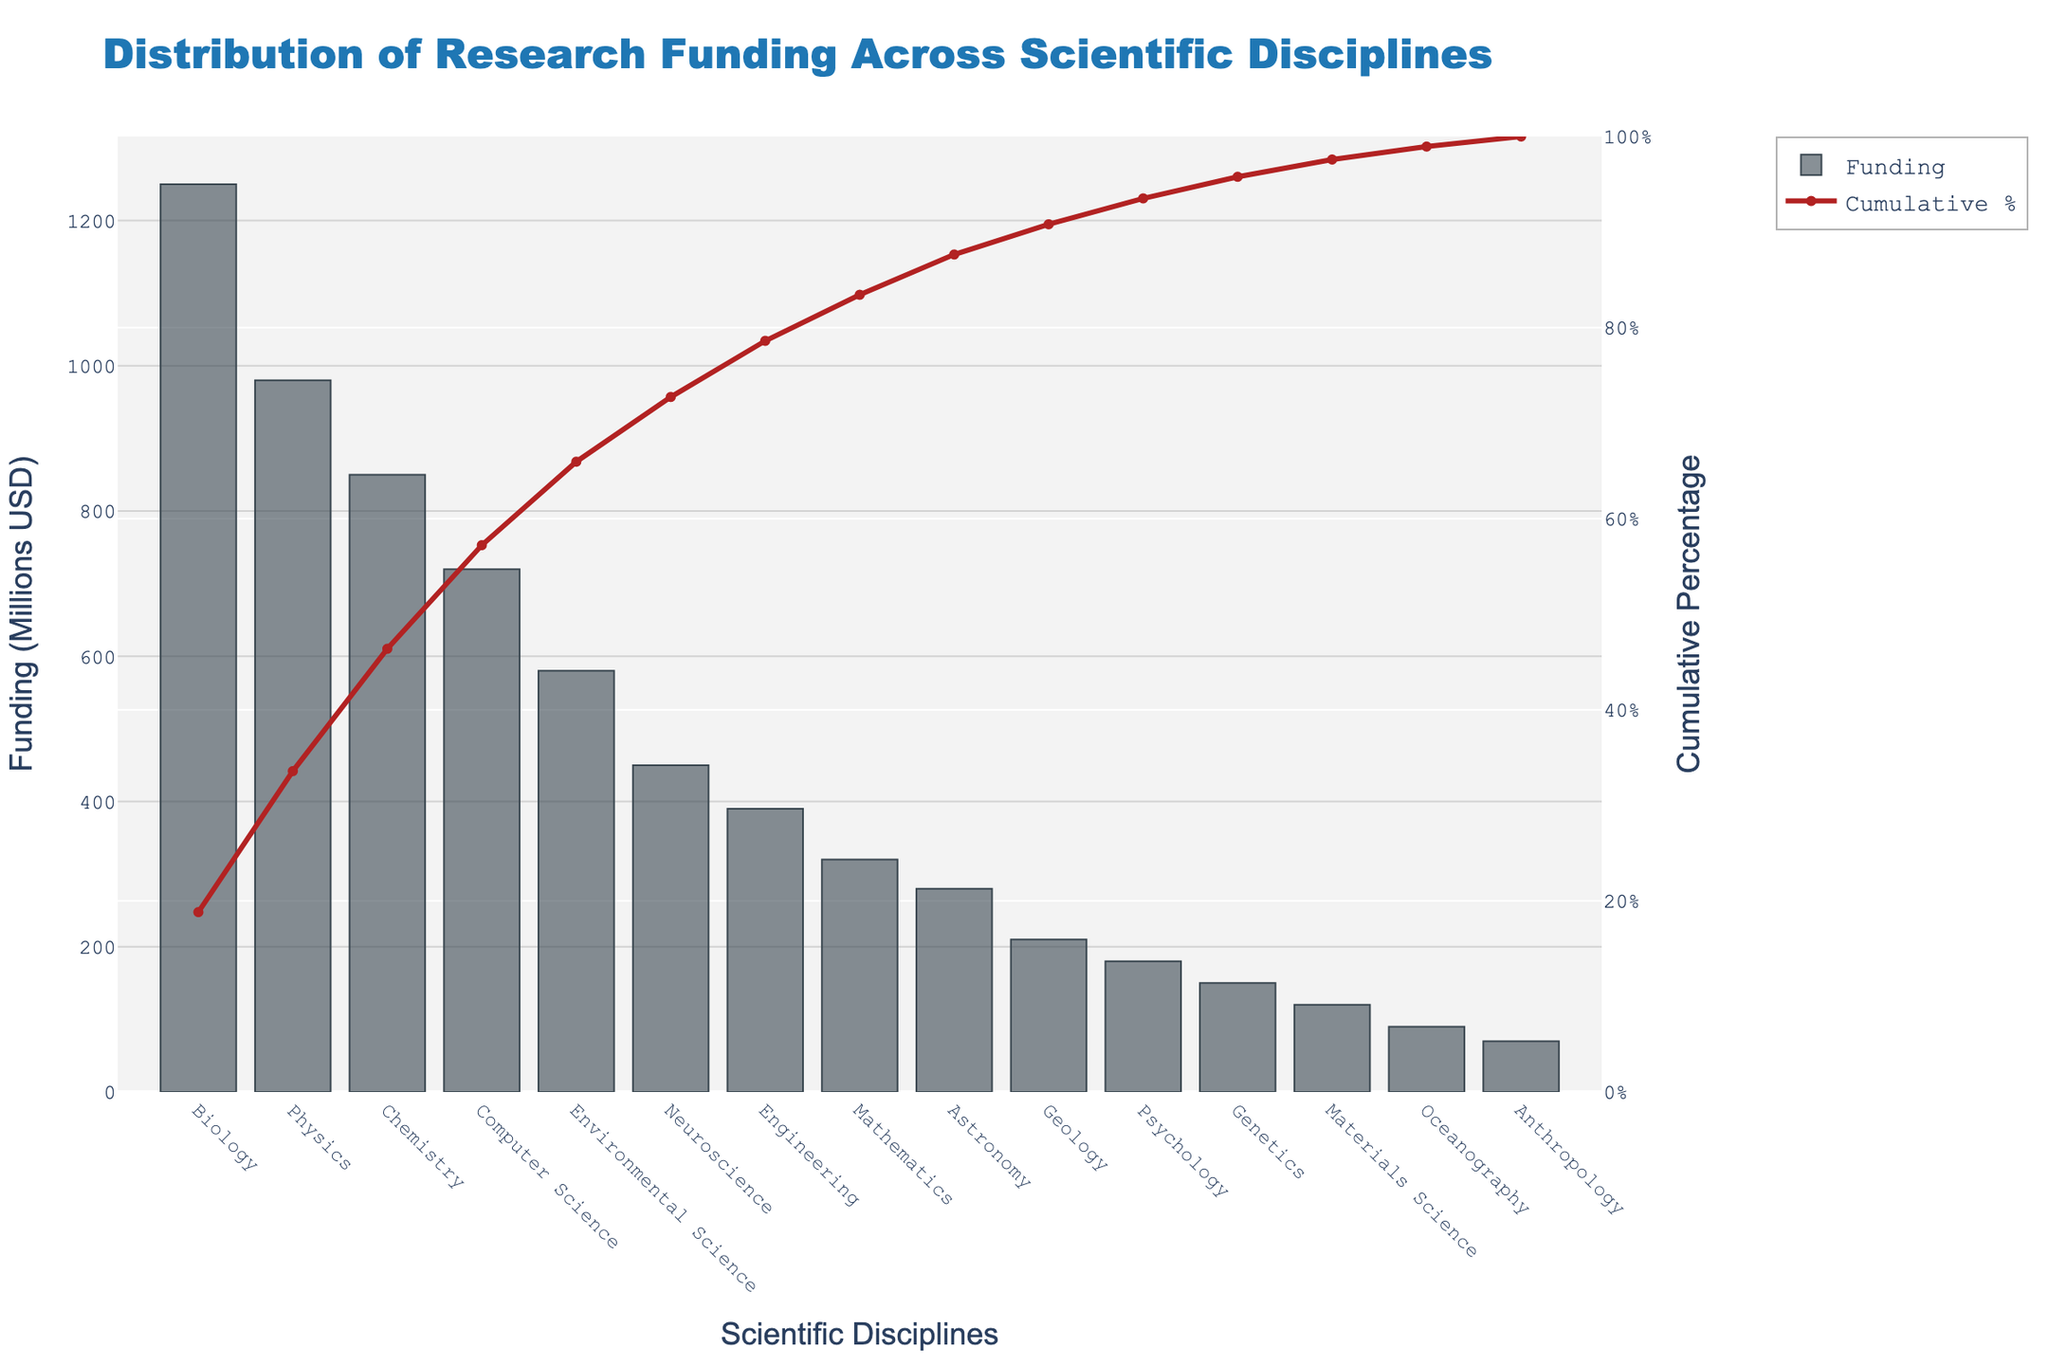What's the total funding amount for Biology and Physics? The funding for Biology is 1250 million USD, and for Physics, it is 980 million USD. Adding these together gives 1250 + 980 = 2230 million USD.
Answer: 2230 million USD What's the cumulative percentage of funding captured by the top three disciplines? The cumulative percentages for Biology, Physics, and Chemistry when sorted by funding are 22.0%, 39.2%, and 54.2%, respectively. Summing these values gives 54.2%.
Answer: 54.2% Which discipline has the lowest funding and how much is it? The discipline with the lowest funding is Anthropology, with a total of 70 million USD.
Answer: Anthropology, 70 million USD By how much does Chemistry's funding exceed that of Neuroscience? Chemistry has 850 million USD and Neuroscience has 450 million USD. The difference is 850 - 450 = 400 million USD.
Answer: 400 million USD What is the funding difference between the highest funded and lowest funded disciplines? The highest funded discipline is Biology with 1250 million USD, and the lowest funded discipline is Anthropology with 70 million USD. The difference is 1250 - 70 = 1180 million USD.
Answer: 1180 million USD Which discipline reaches the cumulative funding percentage of 50%, and is it above or below this value? Chemistry reaches the cumulative funding percentage of 54.2%, which is above 50%.
Answer: Chemistry, above 50% What percentage of the total funding is allocated to the top four disciplines? Adding the cumulative percentages of Biology (22.0%), Physics (39.2%), Chemistry (54.2%), and Computer Science (66.9%) gives the percentage captured by the top four disciplines as 66.9%.
Answer: 66.9% How much more funding does Engineering receive compared to Mathematics? Engineering receives 390 million USD, and Mathematics receives 320 million USD. The difference is 390 - 320 = 70 million USD.
Answer: 70 million USD What is the funding trend after the first five disciplines? After Environmental Science (the fifth discipline), there is a noticeable drop in funding. The funding amounts for the following disciplines decrease, starting from Neuroscience with 450 million USD, down to Anthropology with 70 million USD.
Answer: Decreasing trend 